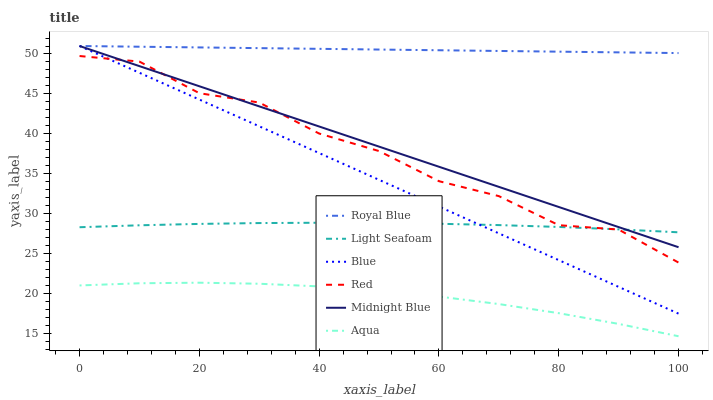Does Aqua have the minimum area under the curve?
Answer yes or no. Yes. Does Royal Blue have the maximum area under the curve?
Answer yes or no. Yes. Does Midnight Blue have the minimum area under the curve?
Answer yes or no. No. Does Midnight Blue have the maximum area under the curve?
Answer yes or no. No. Is Royal Blue the smoothest?
Answer yes or no. Yes. Is Red the roughest?
Answer yes or no. Yes. Is Midnight Blue the smoothest?
Answer yes or no. No. Is Midnight Blue the roughest?
Answer yes or no. No. Does Aqua have the lowest value?
Answer yes or no. Yes. Does Midnight Blue have the lowest value?
Answer yes or no. No. Does Royal Blue have the highest value?
Answer yes or no. Yes. Does Aqua have the highest value?
Answer yes or no. No. Is Aqua less than Royal Blue?
Answer yes or no. Yes. Is Royal Blue greater than Light Seafoam?
Answer yes or no. Yes. Does Blue intersect Red?
Answer yes or no. Yes. Is Blue less than Red?
Answer yes or no. No. Is Blue greater than Red?
Answer yes or no. No. Does Aqua intersect Royal Blue?
Answer yes or no. No. 